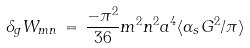<formula> <loc_0><loc_0><loc_500><loc_500>\delta _ { g } W _ { m n } \, = \, { \frac { - \pi ^ { 2 } } { 3 6 } } m ^ { 2 } n ^ { 2 } a ^ { 4 } \langle \alpha _ { s } G ^ { 2 } / \pi \rangle</formula> 